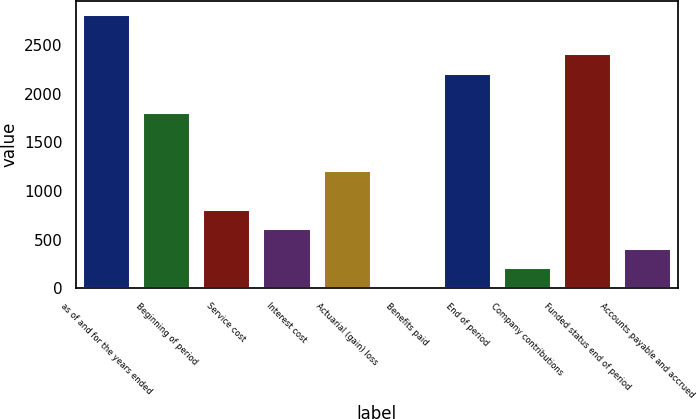Convert chart. <chart><loc_0><loc_0><loc_500><loc_500><bar_chart><fcel>as of and for the years ended<fcel>Beginning of period<fcel>Service cost<fcel>Interest cost<fcel>Actuarial (gain) loss<fcel>Benefits paid<fcel>End of period<fcel>Company contributions<fcel>Funded status end of period<fcel>Accounts payable and accrued<nl><fcel>2817.8<fcel>1816.8<fcel>815.8<fcel>615.6<fcel>1216.2<fcel>15<fcel>2217.2<fcel>215.2<fcel>2417.4<fcel>415.4<nl></chart> 